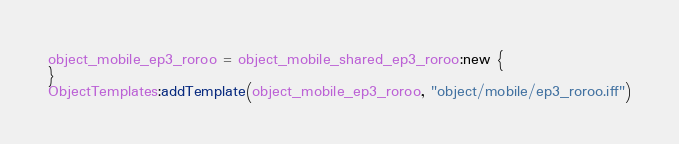Convert code to text. <code><loc_0><loc_0><loc_500><loc_500><_Lua_>object_mobile_ep3_roroo = object_mobile_shared_ep3_roroo:new {}ObjectTemplates:addTemplate(object_mobile_ep3_roroo, "object/mobile/ep3_roroo.iff")</code> 